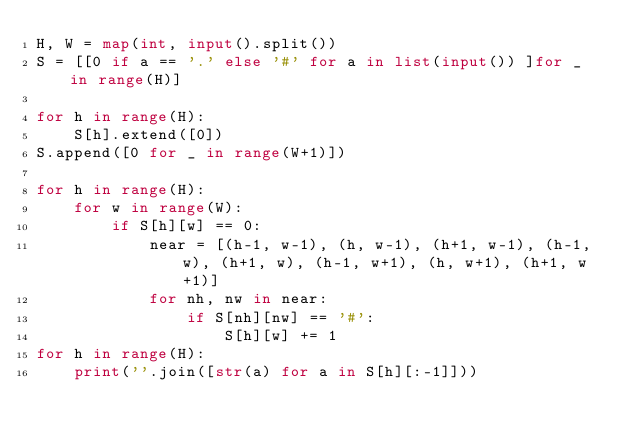<code> <loc_0><loc_0><loc_500><loc_500><_Python_>H, W = map(int, input().split())
S = [[0 if a == '.' else '#' for a in list(input()) ]for _ in range(H)]

for h in range(H):
    S[h].extend([0])
S.append([0 for _ in range(W+1)])

for h in range(H):
    for w in range(W):
        if S[h][w] == 0:
            near = [(h-1, w-1), (h, w-1), (h+1, w-1), (h-1, w), (h+1, w), (h-1, w+1), (h, w+1), (h+1, w+1)]
            for nh, nw in near:
                if S[nh][nw] == '#':
                    S[h][w] += 1
for h in range(H):
    print(''.join([str(a) for a in S[h][:-1]]))</code> 